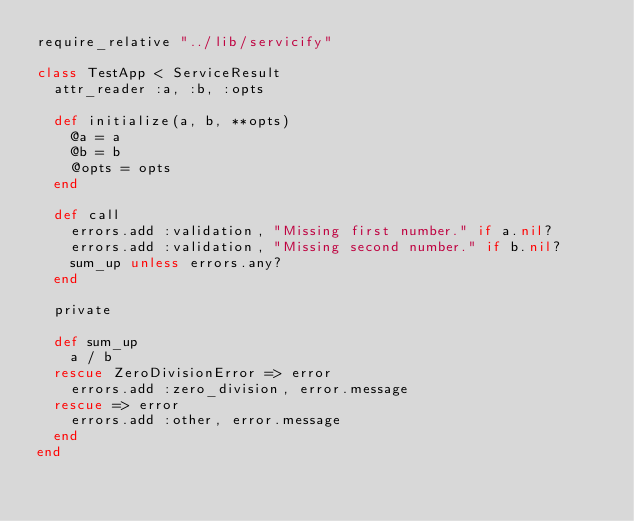Convert code to text. <code><loc_0><loc_0><loc_500><loc_500><_Ruby_>require_relative "../lib/servicify"

class TestApp < ServiceResult
  attr_reader :a, :b, :opts

  def initialize(a, b, **opts)
    @a = a
    @b = b
    @opts = opts
  end

  def call
    errors.add :validation, "Missing first number." if a.nil?
    errors.add :validation, "Missing second number." if b.nil?
    sum_up unless errors.any?
  end

  private

  def sum_up
    a / b
  rescue ZeroDivisionError => error
    errors.add :zero_division, error.message
  rescue => error
    errors.add :other, error.message
  end
end
</code> 